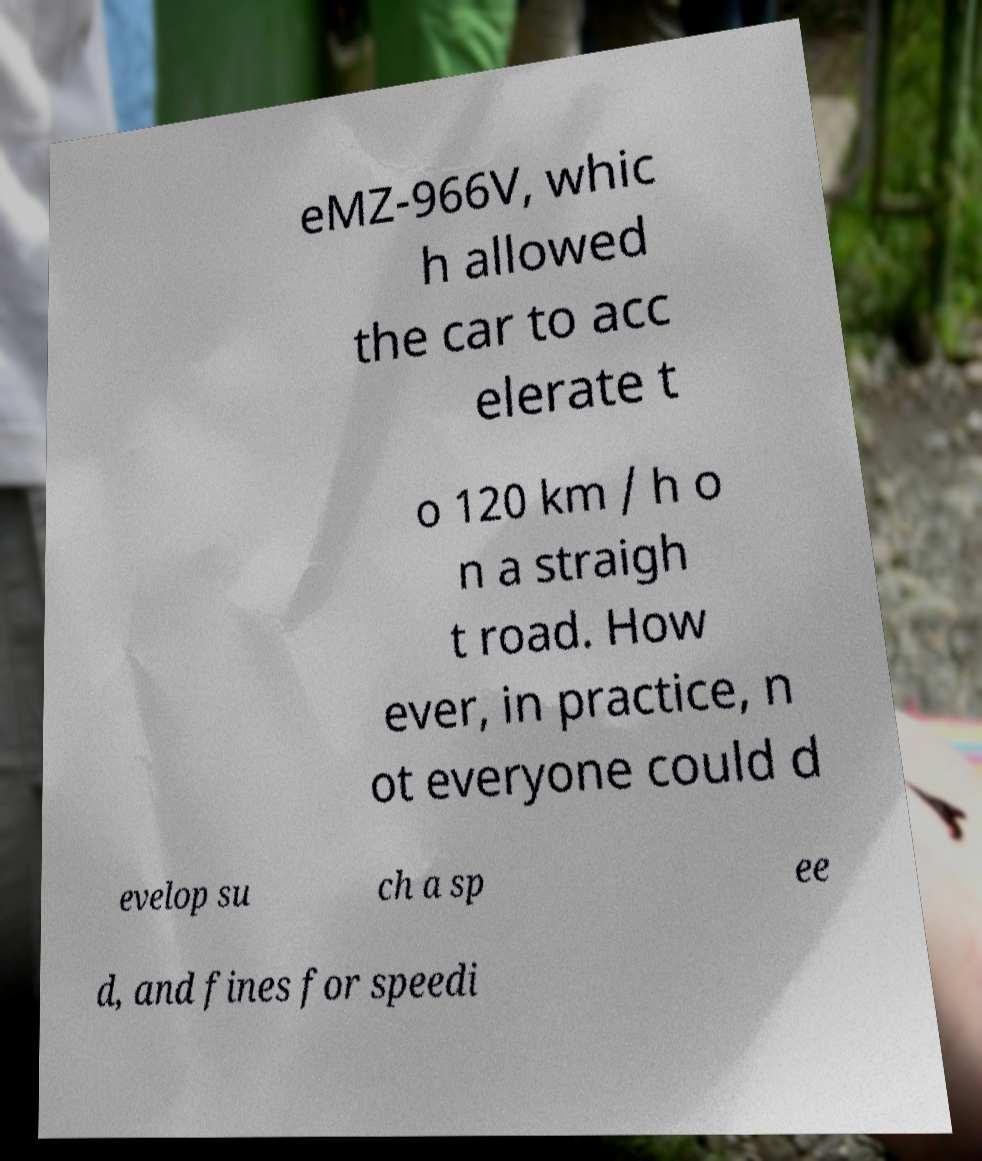There's text embedded in this image that I need extracted. Can you transcribe it verbatim? eMZ-966V, whic h allowed the car to acc elerate t o 120 km / h o n a straigh t road. How ever, in practice, n ot everyone could d evelop su ch a sp ee d, and fines for speedi 